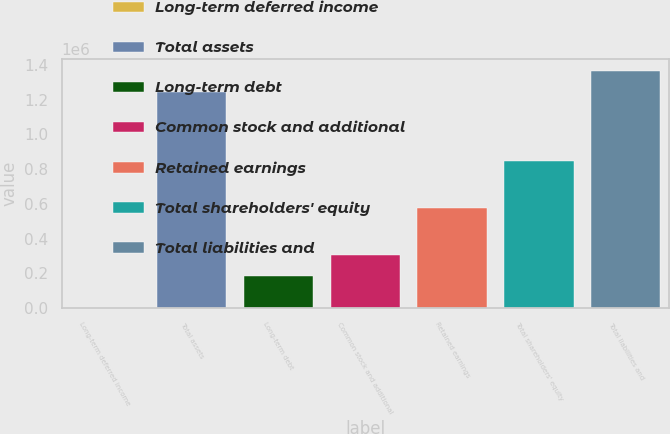Convert chart. <chart><loc_0><loc_0><loc_500><loc_500><bar_chart><fcel>Long-term deferred income<fcel>Total assets<fcel>Long-term debt<fcel>Common stock and additional<fcel>Retained earnings<fcel>Total shareholders' equity<fcel>Total liabilities and<nl><fcel>2217<fcel>1.24108e+06<fcel>182825<fcel>306711<fcel>577090<fcel>844725<fcel>1.36496e+06<nl></chart> 